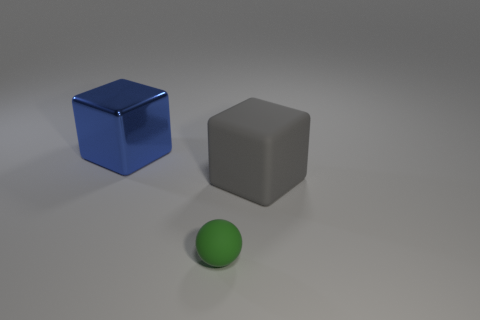How many gray objects are either rubber cubes or cylinders? In the image, there is one gray cube and no gray cylinders present among the objects displayed. 